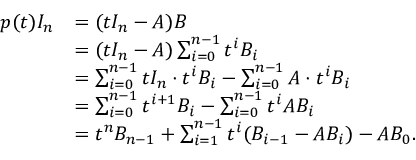<formula> <loc_0><loc_0><loc_500><loc_500>{ \begin{array} { r l } { p ( t ) I _ { n } } & { = ( t I _ { n } - A ) B } \\ & { = ( t I _ { n } - A ) \sum _ { i = 0 } ^ { n - 1 } t ^ { i } B _ { i } } \\ & { = \sum _ { i = 0 } ^ { n - 1 } t I _ { n } \cdot t ^ { i } B _ { i } - \sum _ { i = 0 } ^ { n - 1 } A \cdot t ^ { i } B _ { i } } \\ & { = \sum _ { i = 0 } ^ { n - 1 } t ^ { i + 1 } B _ { i } - \sum _ { i = 0 } ^ { n - 1 } t ^ { i } A B _ { i } } \\ & { = t ^ { n } B _ { n - 1 } + \sum _ { i = 1 } ^ { n - 1 } t ^ { i } ( B _ { i - 1 } - A B _ { i } ) - A B _ { 0 } . } \end{array} }</formula> 